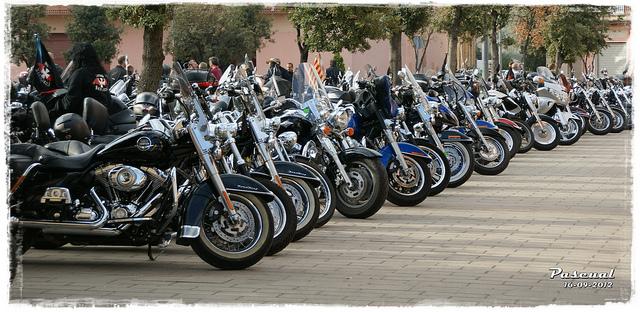Are these mopeds or motorcycles?
Write a very short answer. Motorcycles. Are the bikes on a conveyor belt?
Write a very short answer. No. What color is the ground the motorcycles are sitting on?
Write a very short answer. Gray. Is there only one bike?
Quick response, please. No. 